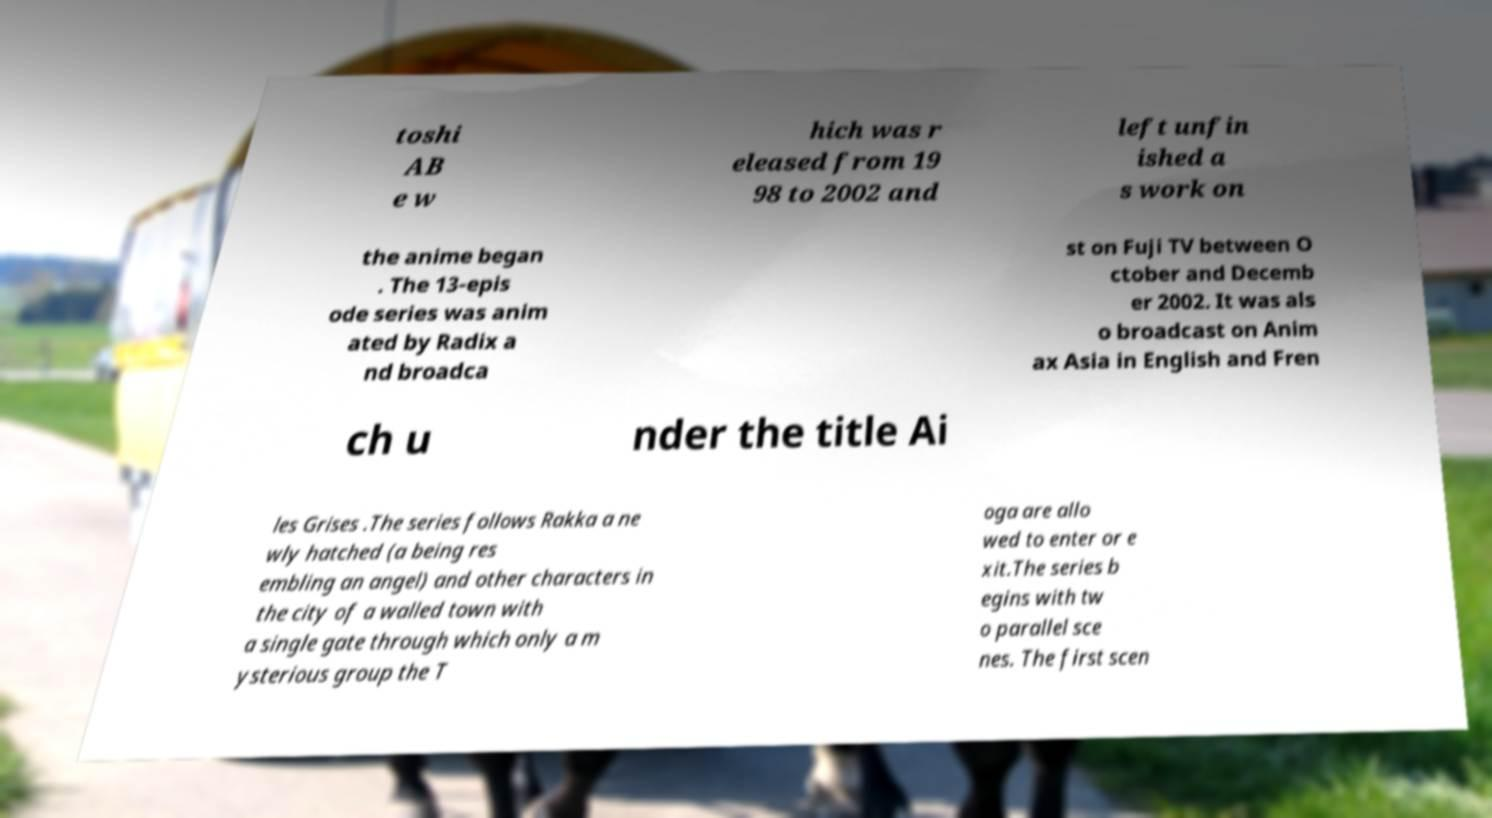Could you extract and type out the text from this image? toshi AB e w hich was r eleased from 19 98 to 2002 and left unfin ished a s work on the anime began . The 13-epis ode series was anim ated by Radix a nd broadca st on Fuji TV between O ctober and Decemb er 2002. It was als o broadcast on Anim ax Asia in English and Fren ch u nder the title Ai les Grises .The series follows Rakka a ne wly hatched (a being res embling an angel) and other characters in the city of a walled town with a single gate through which only a m ysterious group the T oga are allo wed to enter or e xit.The series b egins with tw o parallel sce nes. The first scen 